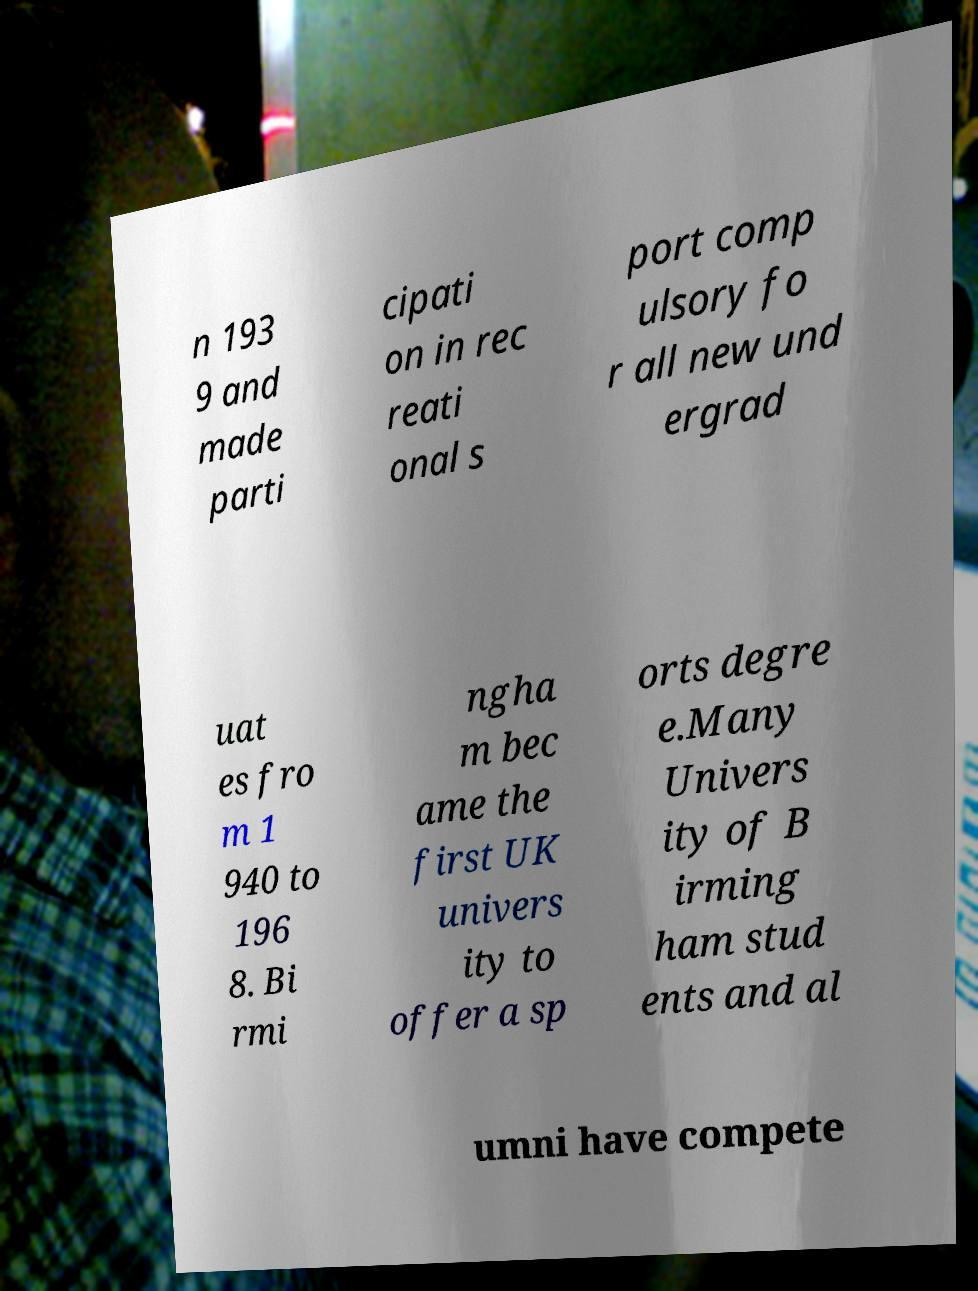Can you accurately transcribe the text from the provided image for me? n 193 9 and made parti cipati on in rec reati onal s port comp ulsory fo r all new und ergrad uat es fro m 1 940 to 196 8. Bi rmi ngha m bec ame the first UK univers ity to offer a sp orts degre e.Many Univers ity of B irming ham stud ents and al umni have compete 